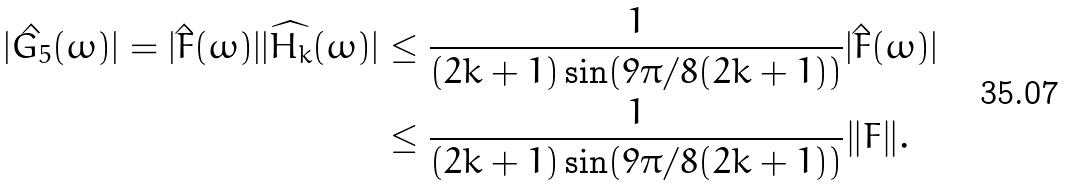Convert formula to latex. <formula><loc_0><loc_0><loc_500><loc_500>| \hat { G _ { 5 } } ( \omega ) | = | \hat { F } ( \omega ) | | \widehat { H _ { k } } ( \omega ) | & \leq \frac { 1 } { ( 2 k + 1 ) \sin ( 9 \pi / 8 ( 2 k + 1 ) ) } | \hat { F } ( \omega ) | \\ & \leq \frac { 1 } { ( 2 k + 1 ) \sin ( 9 \pi / 8 ( 2 k + 1 ) ) } \| F \| .</formula> 